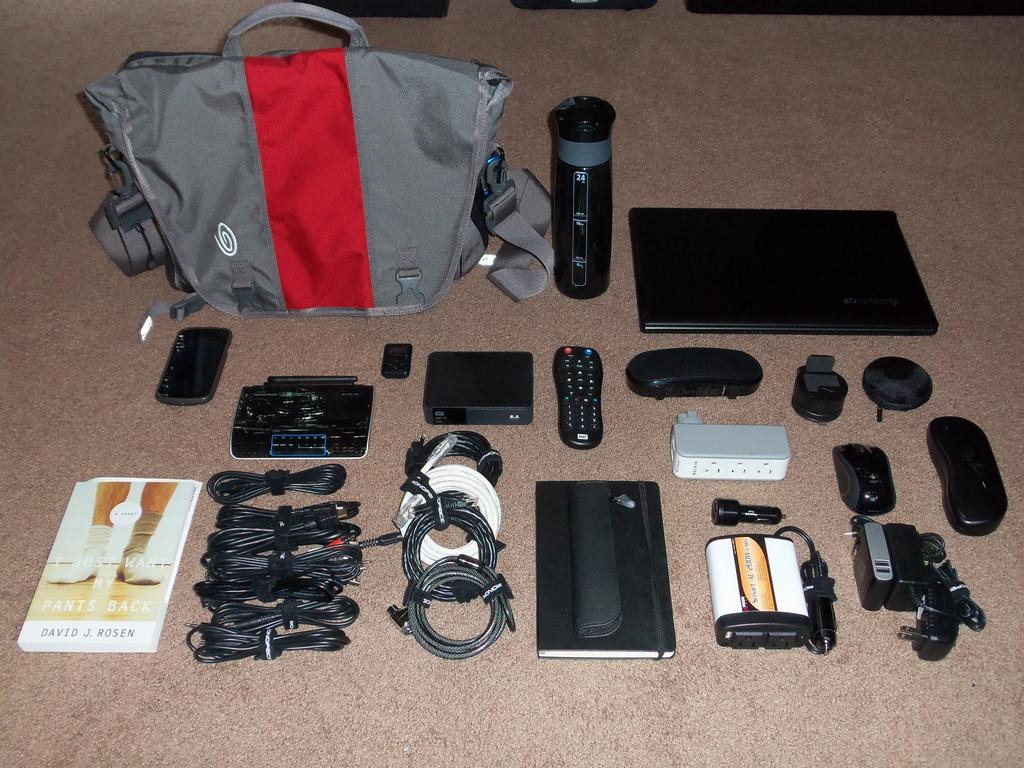Question: where is the scene?
Choices:
A. Floor.
B. Wall.
C. Ceiling.
D. Porch.
Answer with the letter. Answer: A Question: where is the scene?
Choices:
A. Floor.
B. Ceiling.
C. On bar.
D. In restroom.
Answer with the letter. Answer: A Question: who is in the photo?
Choices:
A. The whole crew.
B. The old gang.
C. A barbershop quartet.
D. No one.
Answer with the letter. Answer: D Question: why are the items laid out?
Choices:
A. They're going to be packed.
B. They're being unpacked.
C. To take inventory of what's in the bag.
D. They're searching for a lost item.
Answer with the letter. Answer: C Question: what image is on the book?
Choices:
A. A pirate ship.
B. Two feet.
C. Entangled lovers.
D. A beautiful sunset.
Answer with the letter. Answer: B Question: what color is the carpet?
Choices:
A. Emerald.
B. Black.
C. White.
D. Tan.
Answer with the letter. Answer: D Question: where are the items sitting?
Choices:
A. Shelf.
B. Table.
C. Floor.
D. Bed.
Answer with the letter. Answer: C Question: what is the item in the middle?
Choices:
A. A phone.
B. A garage door opener.
C. A water bottle.
D. A remote control.
Answer with the letter. Answer: D Question: what items are to the right of the book?
Choices:
A. Pens.
B. Cords.
C. Markers.
D. Glasses.
Answer with the letter. Answer: B Question: where was the photo taken?
Choices:
A. On the floor.
B. On the roof.
C. In the truck.
D. In the backseat.
Answer with the letter. Answer: A Question: where is a cell phone?
Choices:
A. In front of the bag.
B. In my purse.
C. On the desk.
D. On the table.
Answer with the letter. Answer: A Question: where is the red button?
Choices:
A. On the television.
B. On the computer.
C. On the remote.
D. On the cell phone.
Answer with the letter. Answer: C Question: what is a book laying beside?
Choices:
A. A lamp.
B. A clock.
C. The cords.
D. A tea cup.
Answer with the letter. Answer: C Question: what has a design on it?
Choices:
A. A shirt.
B. A blanket.
C. The bag.
D. A plate.
Answer with the letter. Answer: C Question: what color is the carpet?
Choices:
A. Red.
B. Tan.
C. Grey.
D. Blue.
Answer with the letter. Answer: B Question: how are most items?
Choices:
A. Round.
B. Tabled.
C. Black.
D. Troubling.
Answer with the letter. Answer: C 